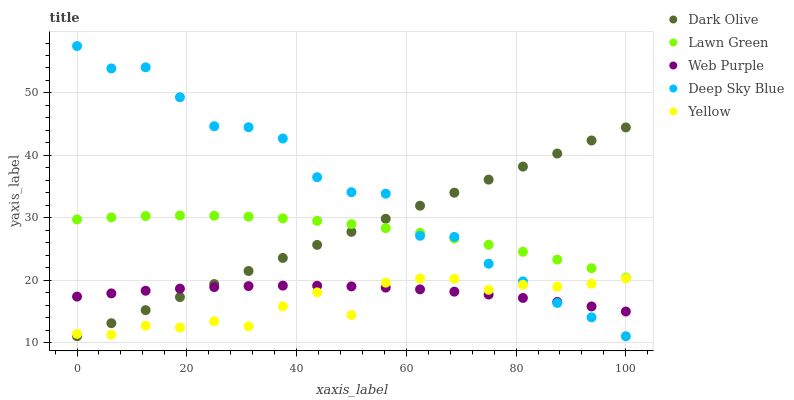Does Yellow have the minimum area under the curve?
Answer yes or no. Yes. Does Deep Sky Blue have the maximum area under the curve?
Answer yes or no. Yes. Does Web Purple have the minimum area under the curve?
Answer yes or no. No. Does Web Purple have the maximum area under the curve?
Answer yes or no. No. Is Dark Olive the smoothest?
Answer yes or no. Yes. Is Deep Sky Blue the roughest?
Answer yes or no. Yes. Is Web Purple the smoothest?
Answer yes or no. No. Is Web Purple the roughest?
Answer yes or no. No. Does Dark Olive have the lowest value?
Answer yes or no. Yes. Does Web Purple have the lowest value?
Answer yes or no. No. Does Deep Sky Blue have the highest value?
Answer yes or no. Yes. Does Dark Olive have the highest value?
Answer yes or no. No. Is Yellow less than Lawn Green?
Answer yes or no. Yes. Is Lawn Green greater than Yellow?
Answer yes or no. Yes. Does Deep Sky Blue intersect Web Purple?
Answer yes or no. Yes. Is Deep Sky Blue less than Web Purple?
Answer yes or no. No. Is Deep Sky Blue greater than Web Purple?
Answer yes or no. No. Does Yellow intersect Lawn Green?
Answer yes or no. No. 